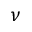Convert formula to latex. <formula><loc_0><loc_0><loc_500><loc_500>\nu</formula> 